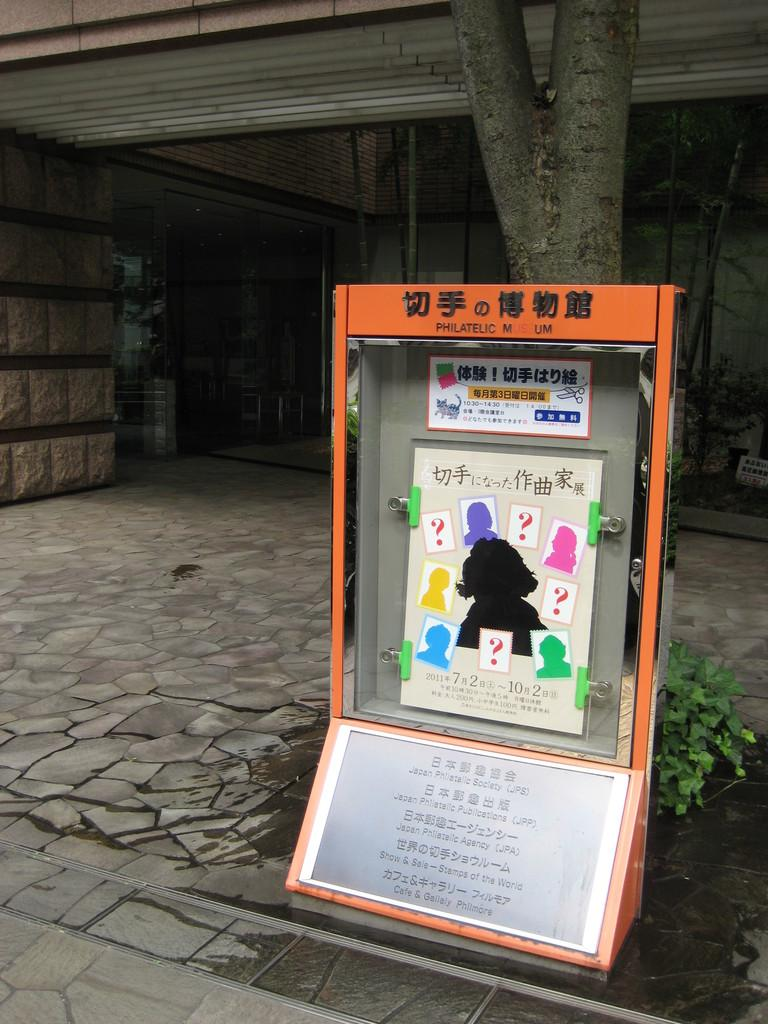What is inside the box that can be seen in the image? There is a board with paper clips inside a box in the image. What type of plant is visible in the image? There is a plant in the image. What can be seen in the background of the image? There are tree trunks and a building in the image. What type of advice can be seen written on the board in the image? There is no advice visible on the board in the image; it is a board with paper clips. Can you see a rifle in the image? There is no rifle present in the image. 